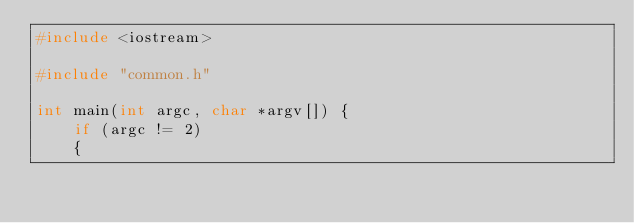<code> <loc_0><loc_0><loc_500><loc_500><_C++_>#include <iostream>

#include "common.h"

int main(int argc, char *argv[]) {
    if (argc != 2)
    {</code> 